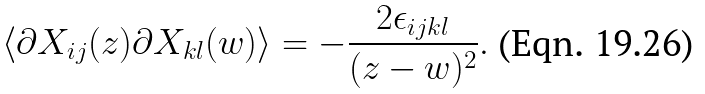<formula> <loc_0><loc_0><loc_500><loc_500>\langle \partial X _ { i j } ( z ) \partial X _ { k l } ( w ) \rangle = - \frac { 2 \epsilon _ { i j k l } } { ( z - w ) ^ { 2 } } .</formula> 